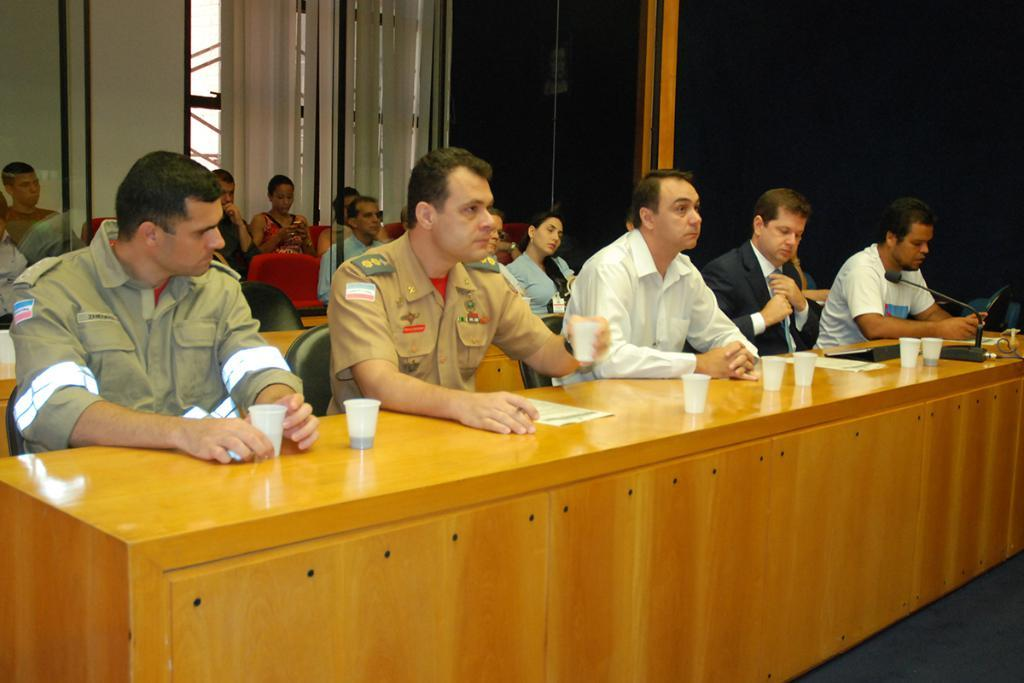What are the people in the room doing? The people are sitting in a room. What objects are in front of the people? There are glasses and papers in front of the people. What device is present for amplifying sound? There is a microphone in front of the people. What type of window treatment is present in the room? There are window blinds at the back of the room. What type of scissors are being used for a haircut in the image? There are no scissors or haircuts present in the image. What type of voyage is being planned by the people in the image? There is no indication of a voyage being planned in the image. 